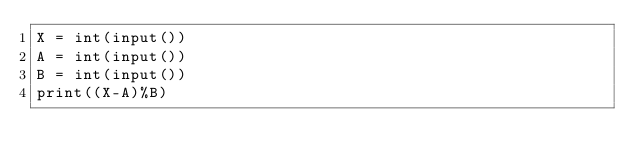Convert code to text. <code><loc_0><loc_0><loc_500><loc_500><_Python_>X = int(input())
A = int(input())
B = int(input())
print((X-A)%B)

</code> 